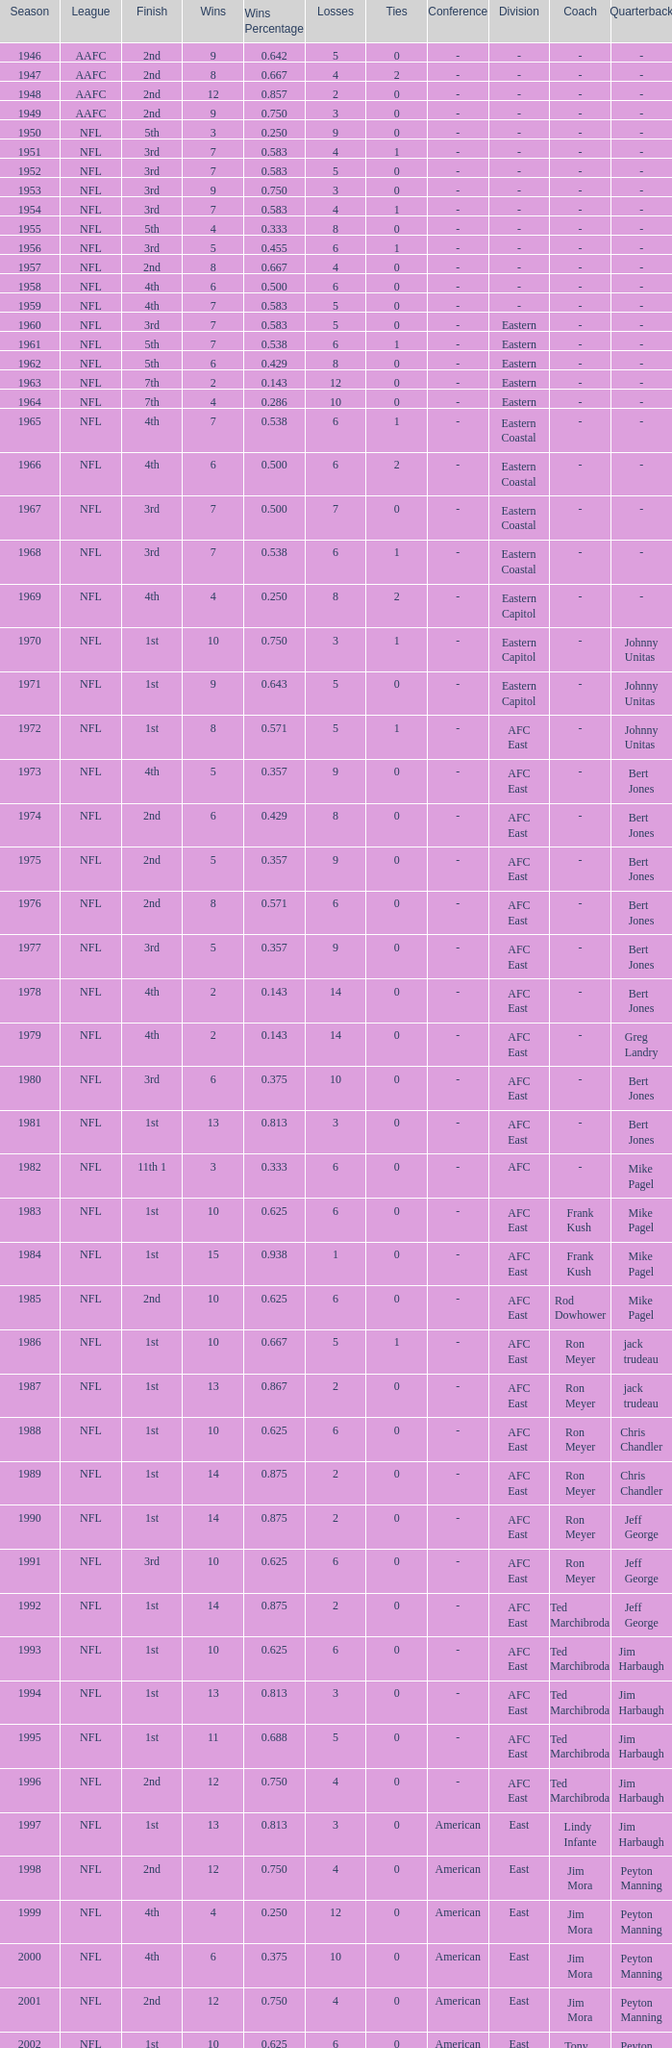What is the number of losses when the ties are lesser than 0? 0.0. Can you give me this table as a dict? {'header': ['Season', 'League', 'Finish', 'Wins', 'Wins Percentage', 'Losses', 'Ties', 'Conference', 'Division', 'Coach', 'Quarterback'], 'rows': [['1946', 'AAFC', '2nd', '9', '0.642', '5', '0', '-', '-', '-', '-'], ['1947', 'AAFC', '2nd', '8', '0.667', '4', '2', '-', '-', '-', '-'], ['1948', 'AAFC', '2nd', '12', '0.857', '2', '0', '-', '-', '-', '-'], ['1949', 'AAFC', '2nd', '9', '0.750', '3', '0', '-', '-', '-', '-'], ['1950', 'NFL', '5th', '3', '0.250', '9', '0', '-', '-', '-', '-'], ['1951', 'NFL', '3rd', '7', '0.583', '4', '1', '-', '-', '-', '-'], ['1952', 'NFL', '3rd', '7', '0.583', '5', '0', '-', '-', '-', '-'], ['1953', 'NFL', '3rd', '9', '0.750', '3', '0', '-', '-', '-', '-'], ['1954', 'NFL', '3rd', '7', '0.583', '4', '1', '-', '-', '-', '-'], ['1955', 'NFL', '5th', '4', '0.333', '8', '0', '-', '-', '-', '-'], ['1956', 'NFL', '3rd', '5', '0.455', '6', '1', '-', '-', '-', '-'], ['1957', 'NFL', '2nd', '8', '0.667', '4', '0', '-', '-', '-', '-'], ['1958', 'NFL', '4th', '6', '0.500', '6', '0', '-', '-', '-', '-'], ['1959', 'NFL', '4th', '7', '0.583', '5', '0', '-', '-', '-', '-'], ['1960', 'NFL', '3rd', '7', '0.583', '5', '0', '-', 'Eastern', '-', '-'], ['1961', 'NFL', '5th', '7', '0.538', '6', '1', '-', 'Eastern', '-', '-'], ['1962', 'NFL', '5th', '6', '0.429', '8', '0', '-', 'Eastern', '-', '-'], ['1963', 'NFL', '7th', '2', '0.143', '12', '0', '-', 'Eastern', '-', '-'], ['1964', 'NFL', '7th', '4', '0.286', '10', '0', '-', 'Eastern', '-', '-'], ['1965', 'NFL', '4th', '7', '0.538', '6', '1', '-', 'Eastern Coastal', '-', '-'], ['1966', 'NFL', '4th', '6', '0.500', '6', '2', '-', 'Eastern Coastal', '-', '-'], ['1967', 'NFL', '3rd', '7', '0.500', '7', '0', '-', 'Eastern Coastal', '-', '-'], ['1968', 'NFL', '3rd', '7', '0.538', '6', '1', '-', 'Eastern Coastal', '-', '-'], ['1969', 'NFL', '4th', '4', '0.250', '8', '2', '-', 'Eastern Capitol', '-', '-'], ['1970', 'NFL', '1st', '10', '0.750', '3', '1', '-', 'Eastern Capitol', '-', 'Johnny Unitas'], ['1971', 'NFL', '1st', '9', '0.643', '5', '0', '-', 'Eastern Capitol', '-', 'Johnny Unitas'], ['1972', 'NFL', '1st', '8', '0.571', '5', '1', '-', 'AFC East', '-', 'Johnny Unitas'], ['1973', 'NFL', '4th', '5', '0.357', '9', '0', '-', 'AFC East', '-', 'Bert Jones'], ['1974', 'NFL', '2nd', '6', '0.429', '8', '0', '-', 'AFC East', '-', 'Bert Jones'], ['1975', 'NFL', '2nd', '5', '0.357', '9', '0', '-', 'AFC East', '-', 'Bert Jones'], ['1976', 'NFL', '2nd', '8', '0.571', '6', '0', '-', 'AFC East', '-', 'Bert Jones'], ['1977', 'NFL', '3rd', '5', '0.357', '9', '0', '-', 'AFC East', '-', 'Bert Jones'], ['1978', 'NFL', '4th', '2', '0.143', '14', '0', '-', 'AFC East', '-', 'Bert Jones'], ['1979', 'NFL', '4th', '2', '0.143', '14', '0', '-', 'AFC East', '-', 'Greg Landry'], ['1980', 'NFL', '3rd', '6', '0.375', '10', '0', '-', 'AFC East', '-', 'Bert Jones'], ['1981', 'NFL', '1st', '13', '0.813', '3', '0', '-', 'AFC East', '-', 'Bert Jones'], ['1982', 'NFL', '11th 1', '3', '0.333', '6', '0', '-', 'AFC', '-', 'Mike Pagel'], ['1983', 'NFL', '1st', '10', '0.625', '6', '0', '-', 'AFC East', 'Frank Kush', 'Mike Pagel'], ['1984', 'NFL', '1st', '15', '0.938', '1', '0', '-', 'AFC East', 'Frank Kush', 'Mike Pagel'], ['1985', 'NFL', '2nd', '10', '0.625', '6', '0', '-', 'AFC East', 'Rod Dowhower', 'Mike Pagel'], ['1986', 'NFL', '1st', '10', '0.667', '5', '1', '-', 'AFC East', 'Ron Meyer', 'jack trudeau'], ['1987', 'NFL', '1st', '13', '0.867', '2', '0', '-', 'AFC East', 'Ron Meyer', 'jack trudeau'], ['1988', 'NFL', '1st', '10', '0.625', '6', '0', '-', 'AFC East', 'Ron Meyer', 'Chris Chandler'], ['1989', 'NFL', '1st', '14', '0.875', '2', '0', '-', 'AFC East', 'Ron Meyer', 'Chris Chandler'], ['1990', 'NFL', '1st', '14', '0.875', '2', '0', '-', 'AFC East', 'Ron Meyer', 'Jeff George'], ['1991', 'NFL', '3rd', '10', '0.625', '6', '0', '-', 'AFC East', 'Ron Meyer', 'Jeff George'], ['1992', 'NFL', '1st', '14', '0.875', '2', '0', '-', 'AFC East', 'Ted Marchibroda', 'Jeff George'], ['1993', 'NFL', '1st', '10', '0.625', '6', '0', '-', 'AFC East', 'Ted Marchibroda', 'Jim Harbaugh'], ['1994', 'NFL', '1st', '13', '0.813', '3', '0', '-', 'AFC East', 'Ted Marchibroda', 'Jim Harbaugh'], ['1995', 'NFL', '1st', '11', '0.688', '5', '0', '-', 'AFC East', 'Ted Marchibroda', 'Jim Harbaugh'], ['1996', 'NFL', '2nd', '12', '0.750', '4', '0', '-', 'AFC East', 'Ted Marchibroda', 'Jim Harbaugh'], ['1997', 'NFL', '1st', '13', '0.813', '3', '0', 'American', 'East', 'Lindy Infante', 'Jim Harbaugh'], ['1998', 'NFL', '2nd', '12', '0.750', '4', '0', 'American', 'East', 'Jim Mora', 'Peyton Manning'], ['1999', 'NFL', '4th', '4', '0.250', '12', '0', 'American', 'East', 'Jim Mora', 'Peyton Manning'], ['2000', 'NFL', '4th', '6', '0.375', '10', '0', 'American', 'East', 'Jim Mora', 'Peyton Manning'], ['2001', 'NFL', '2nd', '12', '0.750', '4', '0', 'American', 'East', 'Jim Mora', 'Peyton Manning'], ['2002', 'NFL', '1st', '10', '0.625', '6', '0', 'American', 'East', 'Tony Dungy', 'Peyton Manning'], ['2003', 'NFL', '3rd', '7', '0.438', '9', '0', 'American', 'South', 'Tony Dungy', 'Peyton Manning'], ['2004', 'NFL', '4th', '2', '0.125', '14', '0', 'American', 'South', 'Tony Dungy', 'Peyton Manning'], ['2005', 'NFL', '4th', '4', '0.250', '12', '0', 'American', 'South', 'Tony Dungy', 'Peyton Manning'], ['2006', 'NFL', '3rd', '7', '0.438', '9', '0', 'American', 'South', 'Tony Dungy', 'Peyton Manning'], ['2007', 'NFL', '3rd', '5', '0.313', '11', '0', 'AFC', 'South', 'Tony Dungy', 'Peyton Manning'], ['2008', 'NFL', '2nd', '7', '0.438', '9', '0', 'AFC', 'South', 'Tony Dungy', 'Peyton Manning'], ['2009', 'NFL', '2nd', '8', '0.500', '8', '0', 'AFC', 'South', 'Jim Caldwell', 'Peyton Manning'], ['2010', 'NFL', '3rd', '6', '0.375', '10', '0', 'AFC', 'South', 'Jim Caldwell', 'Peyton Manning'], ['2011', 'NFL', '1st', '13', '0.813', '3', '0', 'AFC', 'South', 'Jim Caldwell', 'Peyton Manning'], ['2012', 'NFL', '1st', '11', '0.719', '4', '1', 'AFC', 'South', 'Chuck Pagano', 'Andrew Luck'], ['2013', 'NFL', '2nd', '6', '0.750', '2', '0', 'AFC', 'South', 'Chuck Pagano', 'Andrew Luck']]} 